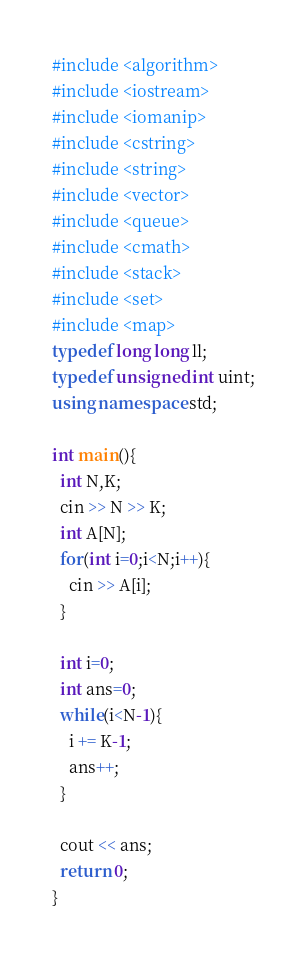Convert code to text. <code><loc_0><loc_0><loc_500><loc_500><_C++_>#include <algorithm>
#include <iostream>
#include <iomanip>
#include <cstring>
#include <string>
#include <vector>
#include <queue>
#include <cmath>
#include <stack>
#include <set>
#include <map>
typedef long long ll;
typedef unsigned int uint;
using namespace std;

int main(){
  int N,K;
  cin >> N >> K;
  int A[N];
  for(int i=0;i<N;i++){
    cin >> A[i];
  }

  int i=0;
  int ans=0;
  while(i<N-1){
    i += K-1;
    ans++;
  }

  cout << ans;
  return 0;
}
</code> 